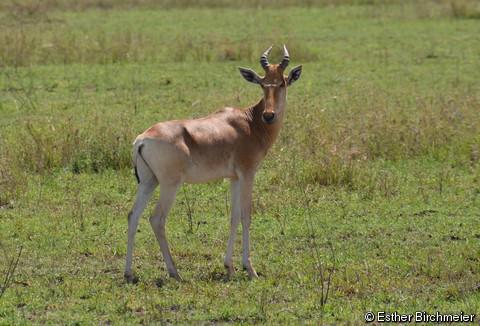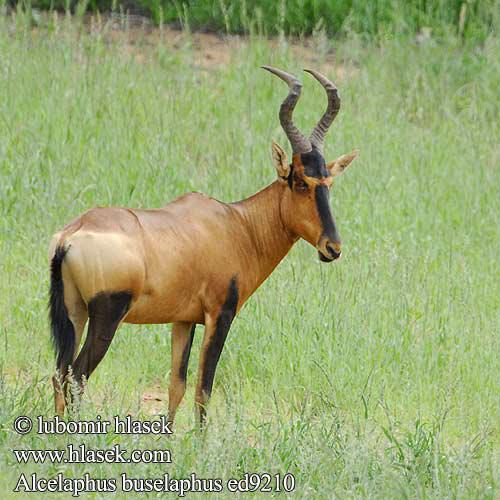The first image is the image on the left, the second image is the image on the right. Considering the images on both sides, is "Each image contains a single horned animal, which is standing on all four legs with its body in profile." valid? Answer yes or no. Yes. The first image is the image on the left, the second image is the image on the right. Considering the images on both sides, is "There are exactly two goats." valid? Answer yes or no. Yes. 